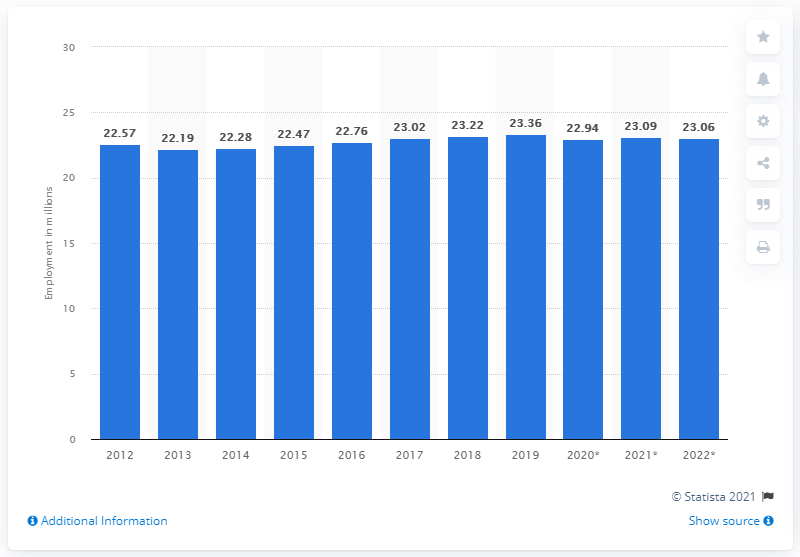Point out several critical features in this image. In 2019, the number of people employed in Italy was 23.36. 